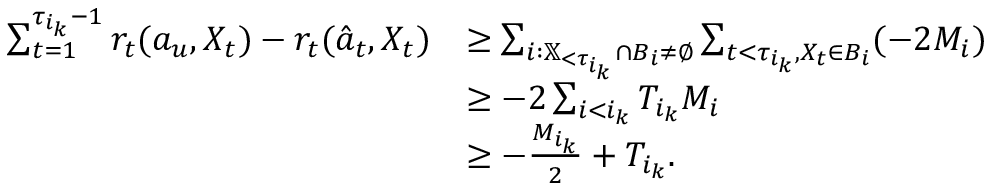Convert formula to latex. <formula><loc_0><loc_0><loc_500><loc_500>\begin{array} { r l } { \sum _ { t = 1 } ^ { \tau _ { i _ { k } } - 1 } r _ { t } ( a _ { u } , X _ { t } ) - r _ { t } ( \hat { a } _ { t } , X _ { t } ) } & { \geq \sum _ { i \colon \mathbb { X } _ { < \tau _ { i _ { k } } } \cap B _ { i } \neq \emptyset } \sum _ { t < \tau _ { i _ { k } } , X _ { t } \in B _ { i } } ( - 2 M _ { i } ) } \\ & { \geq - 2 \sum _ { i < i _ { k } } T _ { i _ { k } } M _ { i } } \\ & { \geq - \frac { M _ { i _ { k } } } { 2 } + T _ { i _ { k } } . } \end{array}</formula> 